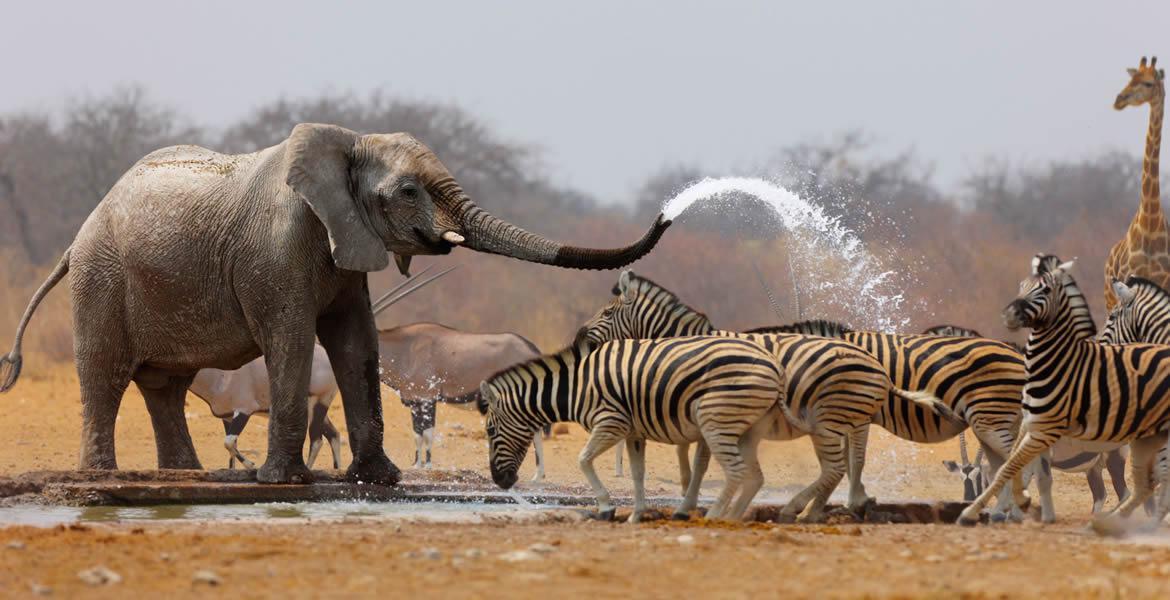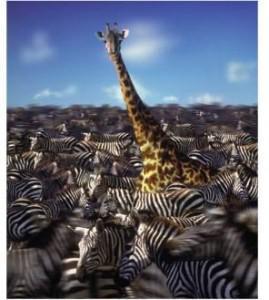The first image is the image on the left, the second image is the image on the right. For the images shown, is this caption "The left image shows a giraffe and at least one other kind of mammal with zebra at a watering hole." true? Answer yes or no. Yes. 